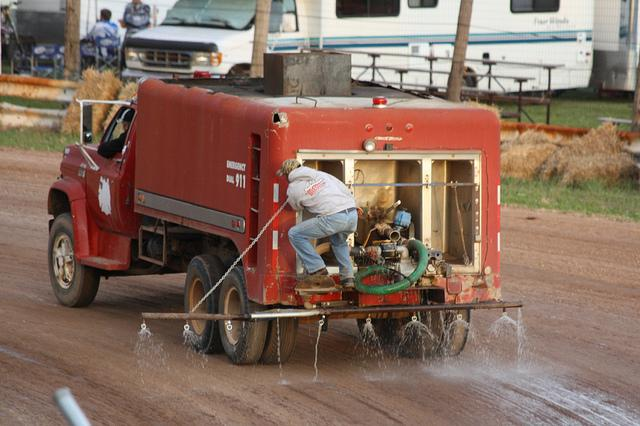How did he get on back of the truck? jumped 